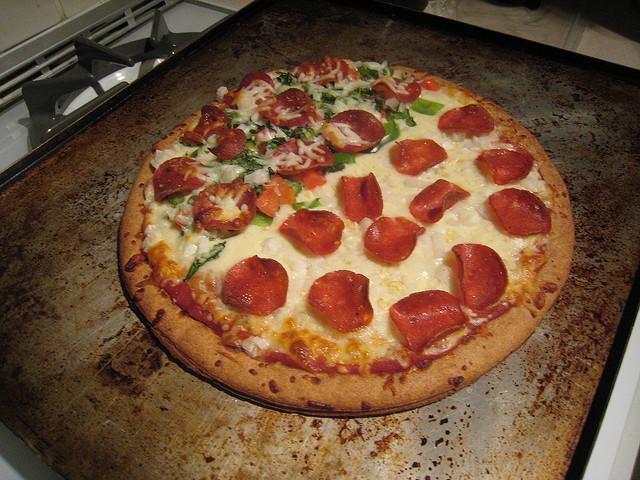Is the statement "The oven is below the pizza." accurate regarding the image?
Answer yes or no. Yes. Is the statement "The pizza is on top of the oven." accurate regarding the image?
Answer yes or no. Yes. 